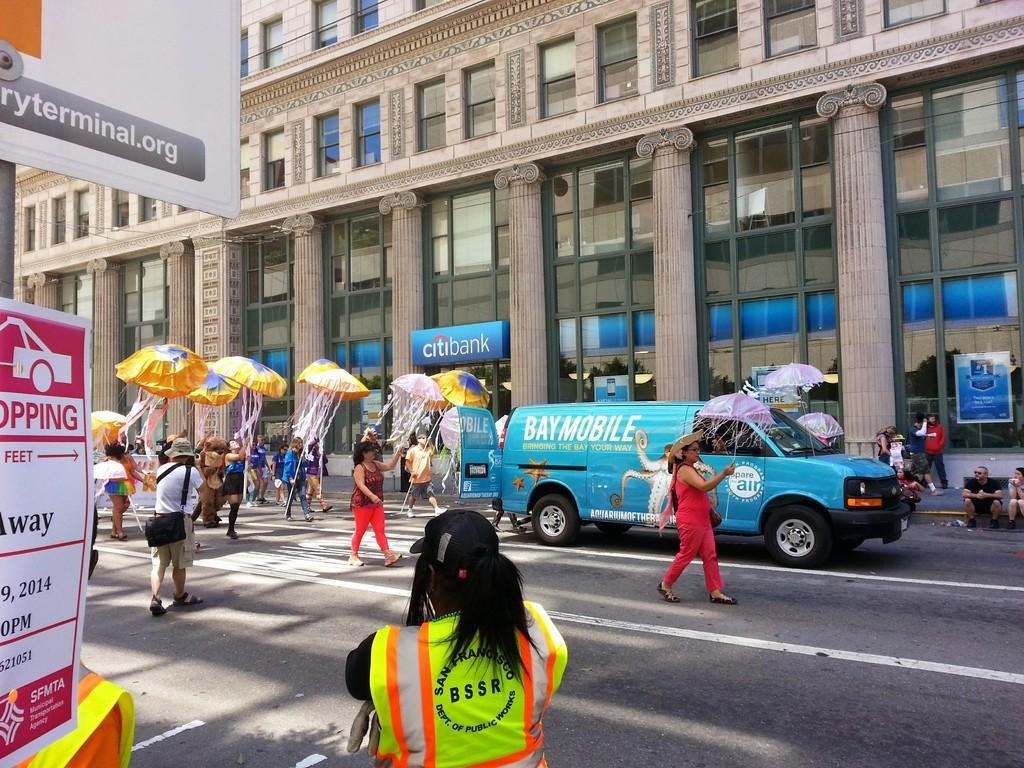Provide a one-sentence caption for the provided image. A Baymobile van passes by the Citibank building, with several people walking behind the van. 